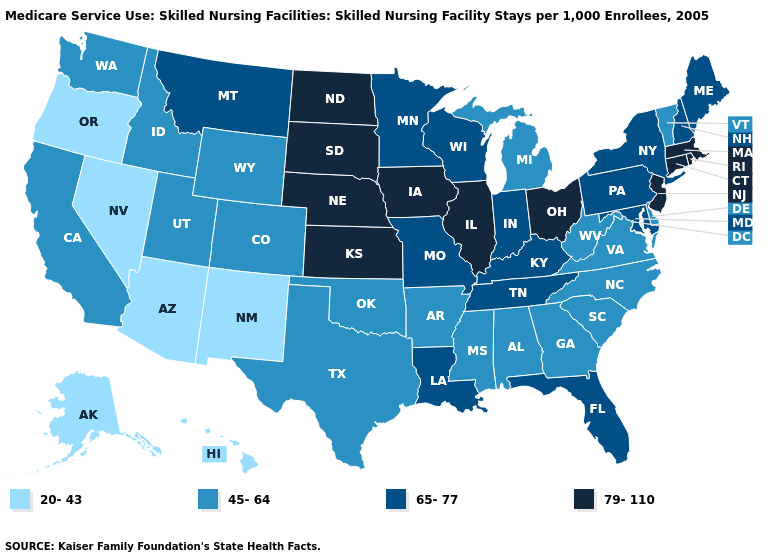How many symbols are there in the legend?
Quick response, please. 4. Name the states that have a value in the range 65-77?
Be succinct. Florida, Indiana, Kentucky, Louisiana, Maine, Maryland, Minnesota, Missouri, Montana, New Hampshire, New York, Pennsylvania, Tennessee, Wisconsin. Does Ohio have a higher value than New Jersey?
Give a very brief answer. No. How many symbols are there in the legend?
Be succinct. 4. Which states have the lowest value in the USA?
Keep it brief. Alaska, Arizona, Hawaii, Nevada, New Mexico, Oregon. Name the states that have a value in the range 65-77?
Be succinct. Florida, Indiana, Kentucky, Louisiana, Maine, Maryland, Minnesota, Missouri, Montana, New Hampshire, New York, Pennsylvania, Tennessee, Wisconsin. What is the value of Michigan?
Quick response, please. 45-64. Does Washington have the highest value in the West?
Write a very short answer. No. What is the highest value in the MidWest ?
Short answer required. 79-110. What is the lowest value in states that border Nebraska?
Give a very brief answer. 45-64. Does Arkansas have the highest value in the USA?
Answer briefly. No. Name the states that have a value in the range 20-43?
Write a very short answer. Alaska, Arizona, Hawaii, Nevada, New Mexico, Oregon. Among the states that border Mississippi , does Tennessee have the highest value?
Short answer required. Yes. What is the value of Wyoming?
Short answer required. 45-64. Does Florida have the highest value in the USA?
Be succinct. No. 